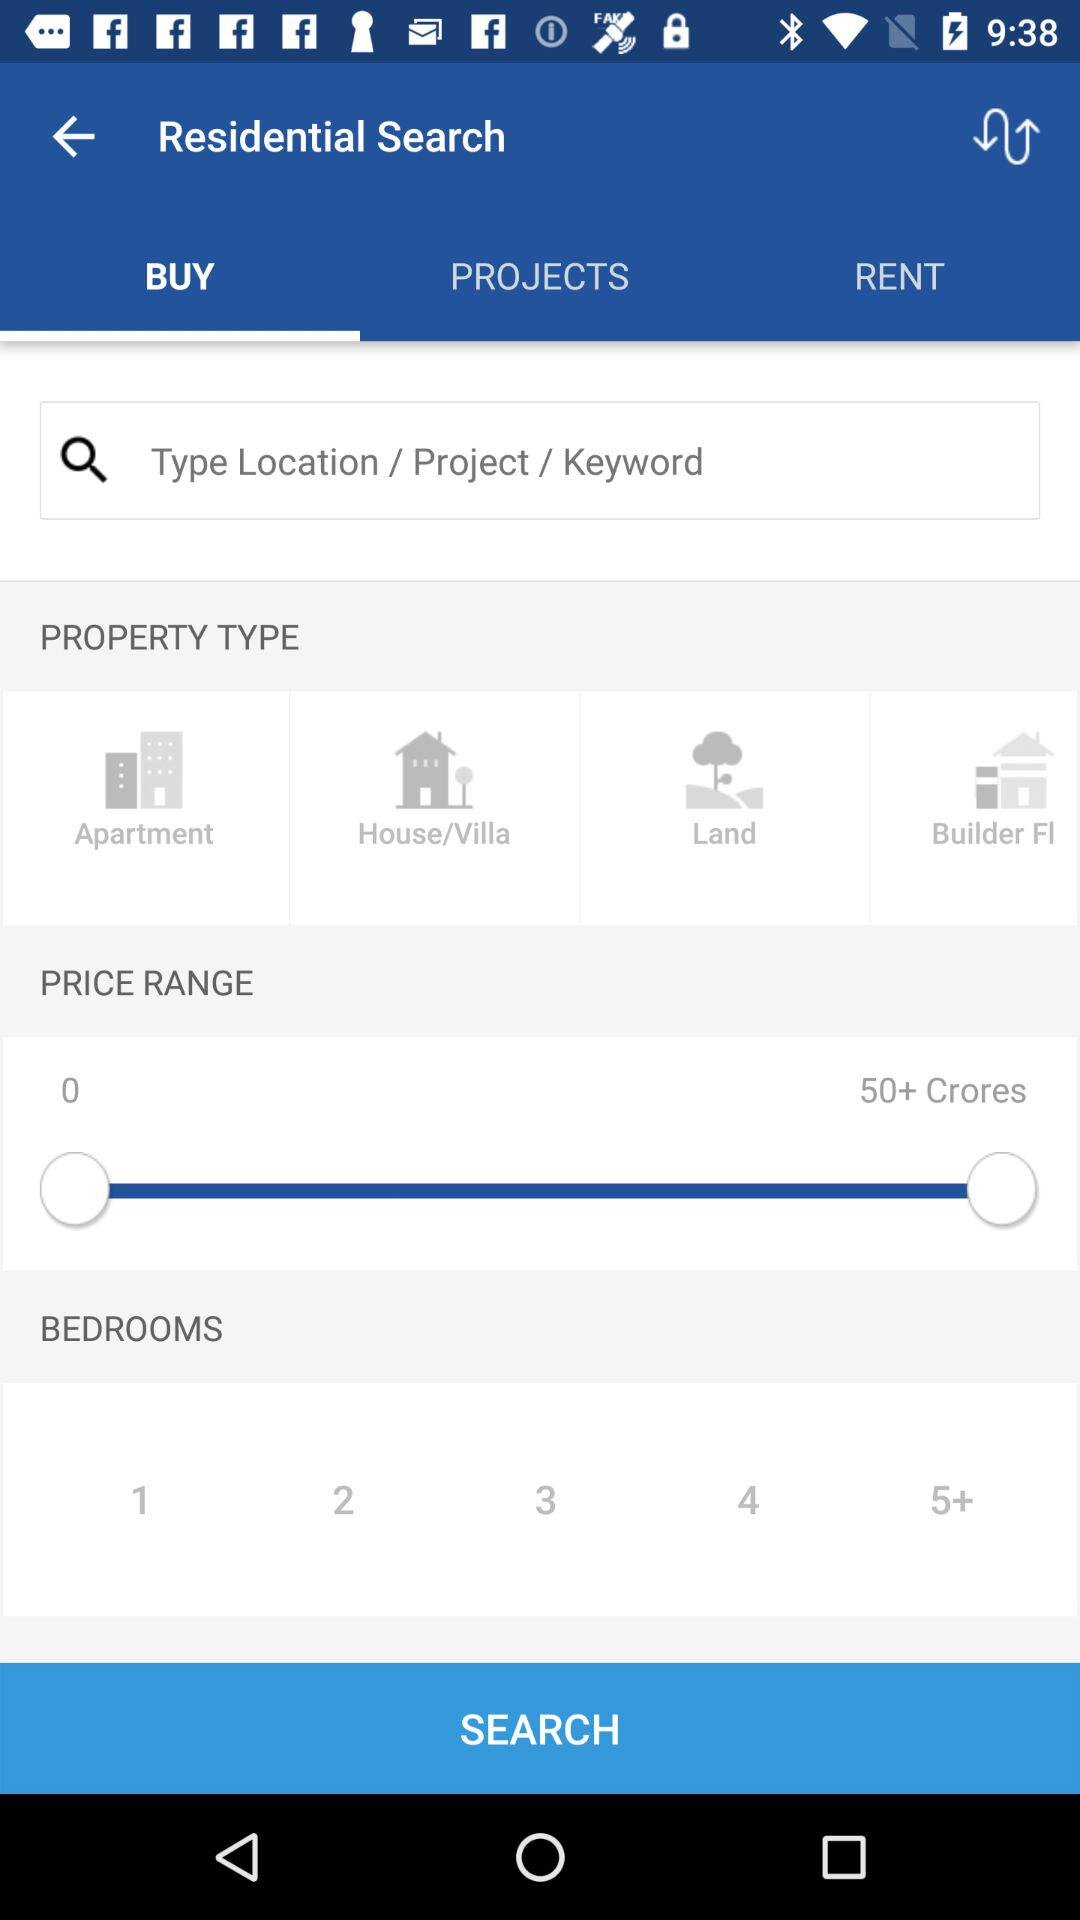What is the selected price range? The price range is between 0 and 50+ Crores. 